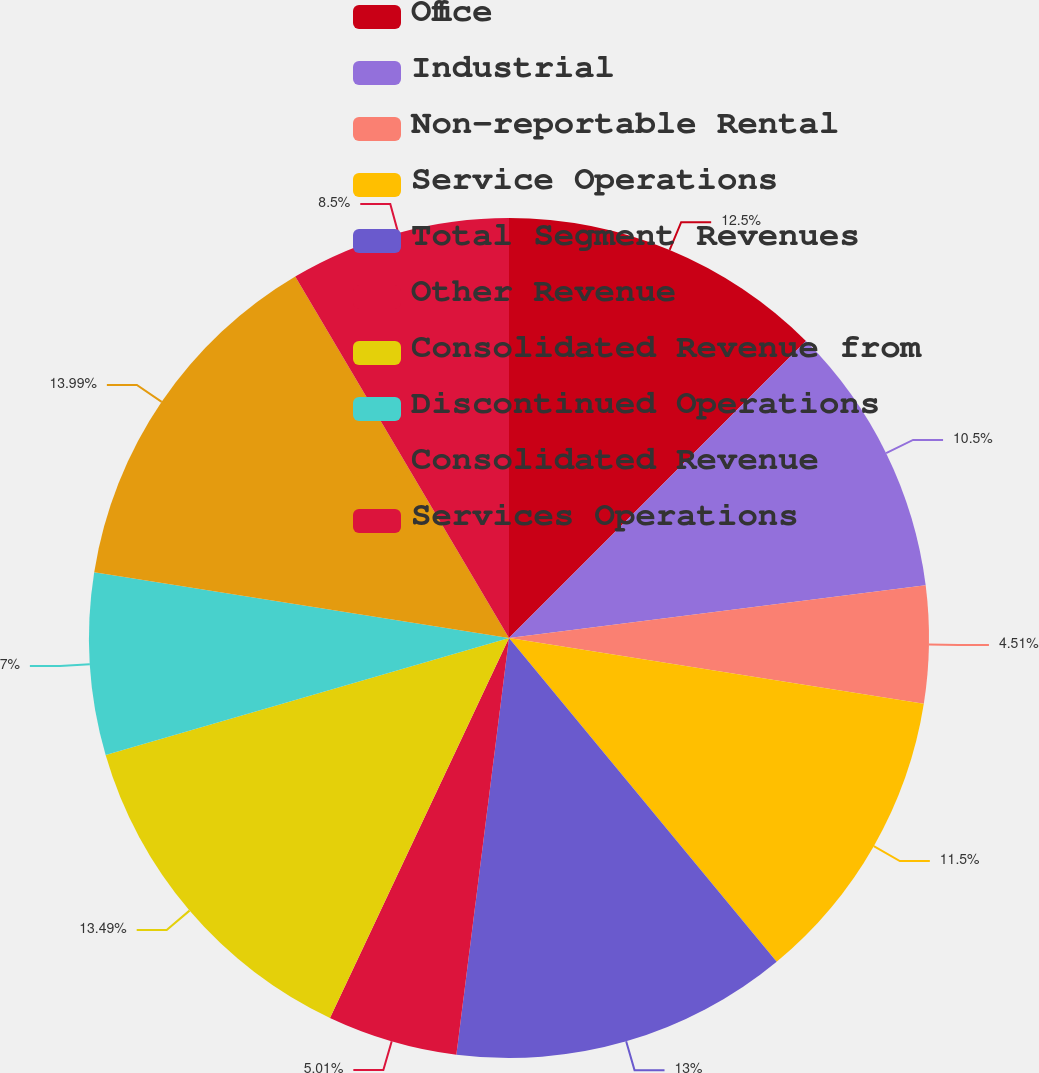Convert chart to OTSL. <chart><loc_0><loc_0><loc_500><loc_500><pie_chart><fcel>Office<fcel>Industrial<fcel>Non-reportable Rental<fcel>Service Operations<fcel>Total Segment Revenues<fcel>Other Revenue<fcel>Consolidated Revenue from<fcel>Discontinued Operations<fcel>Consolidated Revenue<fcel>Services Operations<nl><fcel>12.5%<fcel>10.5%<fcel>4.51%<fcel>11.5%<fcel>13.0%<fcel>5.01%<fcel>13.5%<fcel>7.0%<fcel>14.0%<fcel>8.5%<nl></chart> 